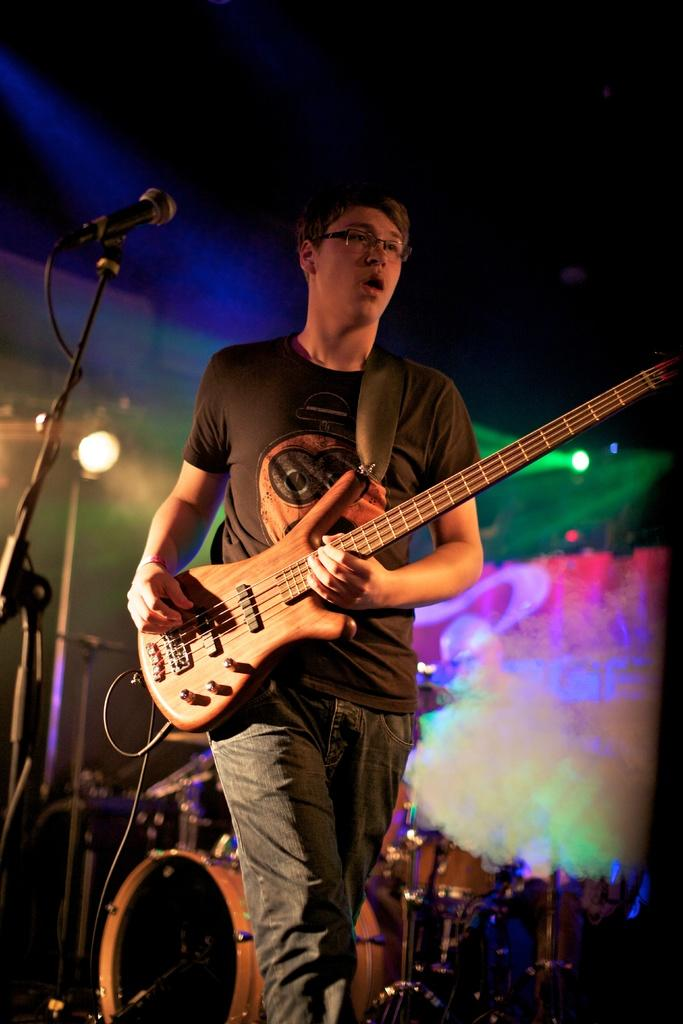What is the person in the image doing? The person is standing and holding a guitar, and they are singing. What object is the person using to amplify their voice? There is a microphone with a stand in the image. What other musical instruments can be seen in the image? There are musical instruments visible behind the person. What type of light is visible in the image? There is a focusing light visible in the image. Can you see the person's aunt in the image? There is no mention of an aunt in the image, so we cannot determine if the person's aunt is present. What color is the sky in the image? The provided facts do not mention the sky, so we cannot determine its color. 